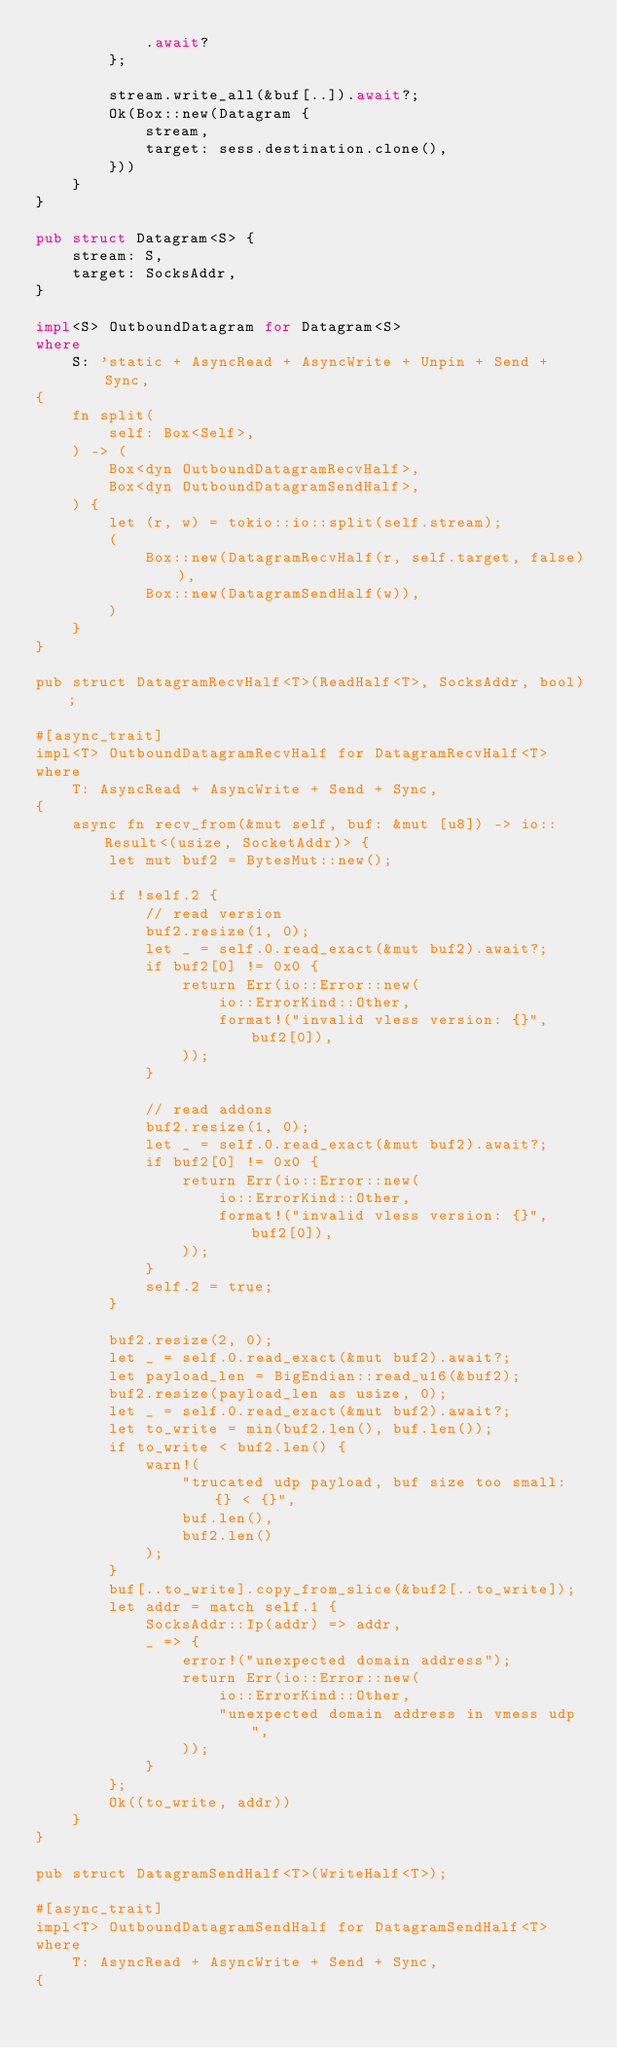<code> <loc_0><loc_0><loc_500><loc_500><_Rust_>            .await?
        };

        stream.write_all(&buf[..]).await?;
        Ok(Box::new(Datagram {
            stream,
            target: sess.destination.clone(),
        }))
    }
}

pub struct Datagram<S> {
    stream: S,
    target: SocksAddr,
}

impl<S> OutboundDatagram for Datagram<S>
where
    S: 'static + AsyncRead + AsyncWrite + Unpin + Send + Sync,
{
    fn split(
        self: Box<Self>,
    ) -> (
        Box<dyn OutboundDatagramRecvHalf>,
        Box<dyn OutboundDatagramSendHalf>,
    ) {
        let (r, w) = tokio::io::split(self.stream);
        (
            Box::new(DatagramRecvHalf(r, self.target, false)),
            Box::new(DatagramSendHalf(w)),
        )
    }
}

pub struct DatagramRecvHalf<T>(ReadHalf<T>, SocksAddr, bool);

#[async_trait]
impl<T> OutboundDatagramRecvHalf for DatagramRecvHalf<T>
where
    T: AsyncRead + AsyncWrite + Send + Sync,
{
    async fn recv_from(&mut self, buf: &mut [u8]) -> io::Result<(usize, SocketAddr)> {
        let mut buf2 = BytesMut::new();

        if !self.2 {
            // read version
            buf2.resize(1, 0);
            let _ = self.0.read_exact(&mut buf2).await?;
            if buf2[0] != 0x0 {
                return Err(io::Error::new(
                    io::ErrorKind::Other,
                    format!("invalid vless version: {}", buf2[0]),
                ));
            }

            // read addons
            buf2.resize(1, 0);
            let _ = self.0.read_exact(&mut buf2).await?;
            if buf2[0] != 0x0 {
                return Err(io::Error::new(
                    io::ErrorKind::Other,
                    format!("invalid vless version: {}", buf2[0]),
                ));
            }
            self.2 = true;
        }

        buf2.resize(2, 0);
        let _ = self.0.read_exact(&mut buf2).await?;
        let payload_len = BigEndian::read_u16(&buf2);
        buf2.resize(payload_len as usize, 0);
        let _ = self.0.read_exact(&mut buf2).await?;
        let to_write = min(buf2.len(), buf.len());
        if to_write < buf2.len() {
            warn!(
                "trucated udp payload, buf size too small: {} < {}",
                buf.len(),
                buf2.len()
            );
        }
        buf[..to_write].copy_from_slice(&buf2[..to_write]);
        let addr = match self.1 {
            SocksAddr::Ip(addr) => addr,
            _ => {
                error!("unexpected domain address");
                return Err(io::Error::new(
                    io::ErrorKind::Other,
                    "unexpected domain address in vmess udp",
                ));
            }
        };
        Ok((to_write, addr))
    }
}

pub struct DatagramSendHalf<T>(WriteHalf<T>);

#[async_trait]
impl<T> OutboundDatagramSendHalf for DatagramSendHalf<T>
where
    T: AsyncRead + AsyncWrite + Send + Sync,
{</code> 